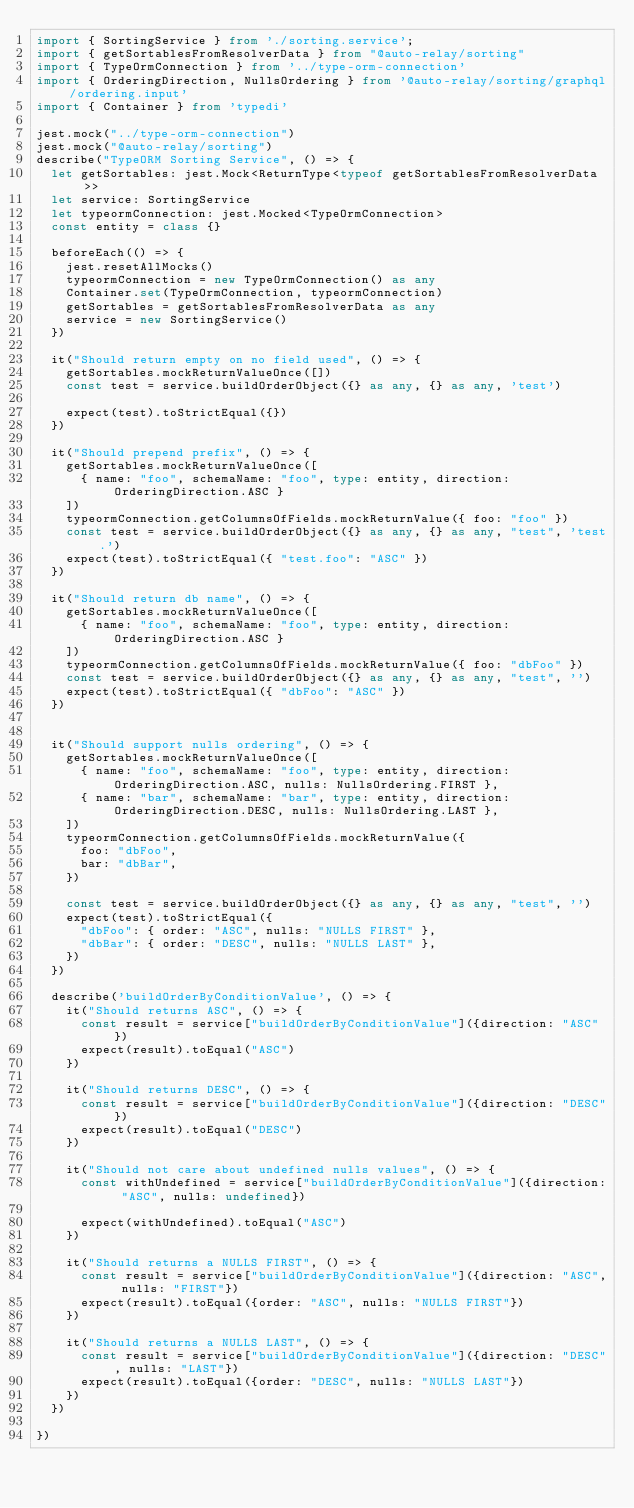<code> <loc_0><loc_0><loc_500><loc_500><_TypeScript_>import { SortingService } from './sorting.service';
import { getSortablesFromResolverData } from "@auto-relay/sorting"
import { TypeOrmConnection } from '../type-orm-connection'
import { OrderingDirection, NullsOrdering } from '@auto-relay/sorting/graphql/ordering.input'
import { Container } from 'typedi'

jest.mock("../type-orm-connection")
jest.mock("@auto-relay/sorting")
describe("TypeORM Sorting Service", () => {
  let getSortables: jest.Mock<ReturnType<typeof getSortablesFromResolverData>>
  let service: SortingService
  let typeormConnection: jest.Mocked<TypeOrmConnection>
  const entity = class {}

  beforeEach(() => {
    jest.resetAllMocks()
    typeormConnection = new TypeOrmConnection() as any
    Container.set(TypeOrmConnection, typeormConnection)
    getSortables = getSortablesFromResolverData as any
    service = new SortingService()
  })

  it("Should return empty on no field used", () => {
    getSortables.mockReturnValueOnce([])
    const test = service.buildOrderObject({} as any, {} as any, 'test')

    expect(test).toStrictEqual({})
  })

  it("Should prepend prefix", () => {
    getSortables.mockReturnValueOnce([
      { name: "foo", schemaName: "foo", type: entity, direction: OrderingDirection.ASC }
    ])
    typeormConnection.getColumnsOfFields.mockReturnValue({ foo: "foo" })
    const test = service.buildOrderObject({} as any, {} as any, "test", 'test.')
    expect(test).toStrictEqual({ "test.foo": "ASC" })
  })

  it("Should return db name", () => {
    getSortables.mockReturnValueOnce([
      { name: "foo", schemaName: "foo", type: entity, direction: OrderingDirection.ASC }
    ])
    typeormConnection.getColumnsOfFields.mockReturnValue({ foo: "dbFoo" })
    const test = service.buildOrderObject({} as any, {} as any, "test", '')
    expect(test).toStrictEqual({ "dbFoo": "ASC" })
  })

  
  it("Should support nulls ordering", () => {
    getSortables.mockReturnValueOnce([
      { name: "foo", schemaName: "foo", type: entity, direction: OrderingDirection.ASC, nulls: NullsOrdering.FIRST },
      { name: "bar", schemaName: "bar", type: entity, direction: OrderingDirection.DESC, nulls: NullsOrdering.LAST },
    ])
    typeormConnection.getColumnsOfFields.mockReturnValue({ 
      foo: "dbFoo",
      bar: "dbBar",
    })

    const test = service.buildOrderObject({} as any, {} as any, "test", '')
    expect(test).toStrictEqual({ 
      "dbFoo": { order: "ASC", nulls: "NULLS FIRST" },
      "dbBar": { order: "DESC", nulls: "NULLS LAST" },
    })
  })

  describe('buildOrderByConditionValue', () => {
    it("Should returns ASC", () => {
      const result = service["buildOrderByConditionValue"]({direction: "ASC"})
      expect(result).toEqual("ASC")
    })

    it("Should returns DESC", () => {
      const result = service["buildOrderByConditionValue"]({direction: "DESC"})
      expect(result).toEqual("DESC")
    })

    it("Should not care about undefined nulls values", () => {
      const withUndefined = service["buildOrderByConditionValue"]({direction: "ASC", nulls: undefined})

      expect(withUndefined).toEqual("ASC")
    })

    it("Should returns a NULLS FIRST", () => {
      const result = service["buildOrderByConditionValue"]({direction: "ASC", nulls: "FIRST"})
      expect(result).toEqual({order: "ASC", nulls: "NULLS FIRST"})
    })

    it("Should returns a NULLS LAST", () => {
      const result = service["buildOrderByConditionValue"]({direction: "DESC", nulls: "LAST"})
      expect(result).toEqual({order: "DESC", nulls: "NULLS LAST"})
    })
  })

})</code> 